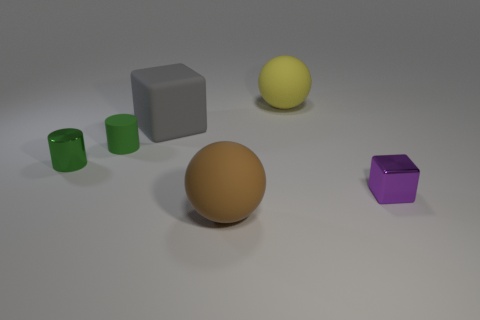Are there any other things that have the same material as the big yellow sphere?
Give a very brief answer. Yes. How many objects are either big brown metallic cubes or large matte things?
Provide a short and direct response. 3. There is another object that is the same shape as the large brown matte thing; what is its size?
Your answer should be very brief. Large. Is the number of tiny green rubber cylinders in front of the tiny green shiny cylinder greater than the number of matte objects?
Give a very brief answer. No. Do the gray thing and the yellow ball have the same material?
Provide a short and direct response. Yes. What number of objects are small metal objects that are to the right of the big gray thing or shiny things to the left of the tiny metal cube?
Your answer should be very brief. 2. The other large thing that is the same shape as the big yellow object is what color?
Your response must be concise. Brown. How many other tiny cylinders are the same color as the shiny cylinder?
Your answer should be very brief. 1. Is the color of the small shiny block the same as the matte cylinder?
Make the answer very short. No. How many things are rubber objects in front of the purple cube or big rubber balls?
Your response must be concise. 2. 